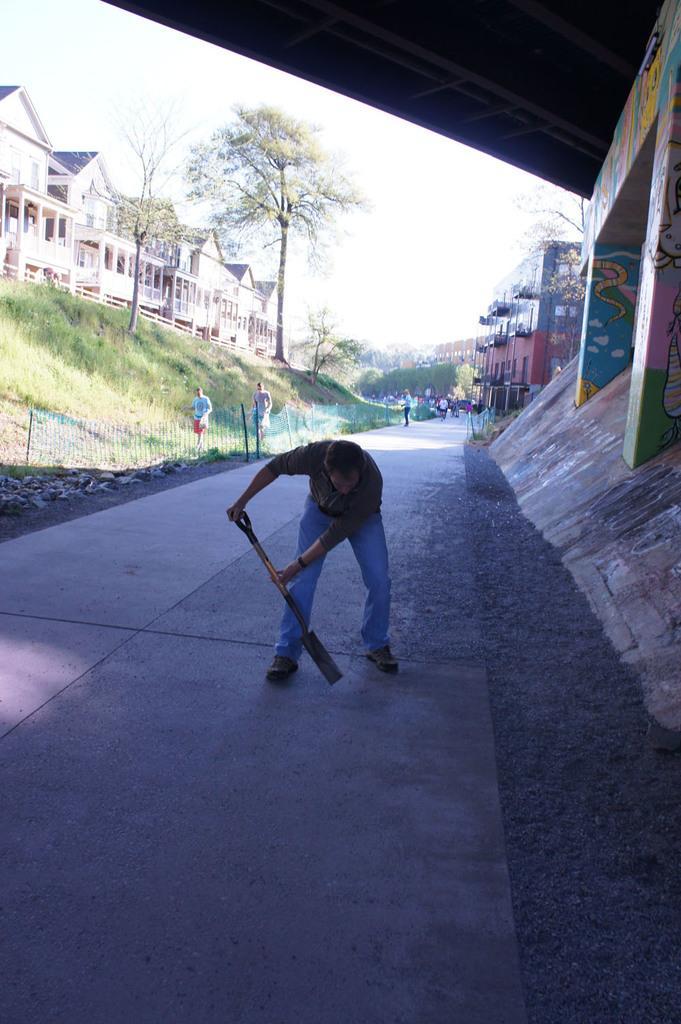Can you describe this image briefly? In the middle a man is there, he is holding the tool with his hands, on the left side there are trees and buildings in this image. 